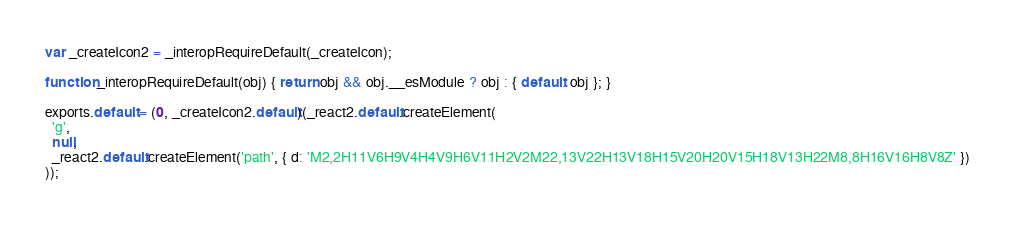Convert code to text. <code><loc_0><loc_0><loc_500><loc_500><_JavaScript_>
var _createIcon2 = _interopRequireDefault(_createIcon);

function _interopRequireDefault(obj) { return obj && obj.__esModule ? obj : { default: obj }; }

exports.default = (0, _createIcon2.default)(_react2.default.createElement(
  'g',
  null,
  _react2.default.createElement('path', { d: 'M2,2H11V6H9V4H4V9H6V11H2V2M22,13V22H13V18H15V20H20V15H18V13H22M8,8H16V16H8V8Z' })
));</code> 